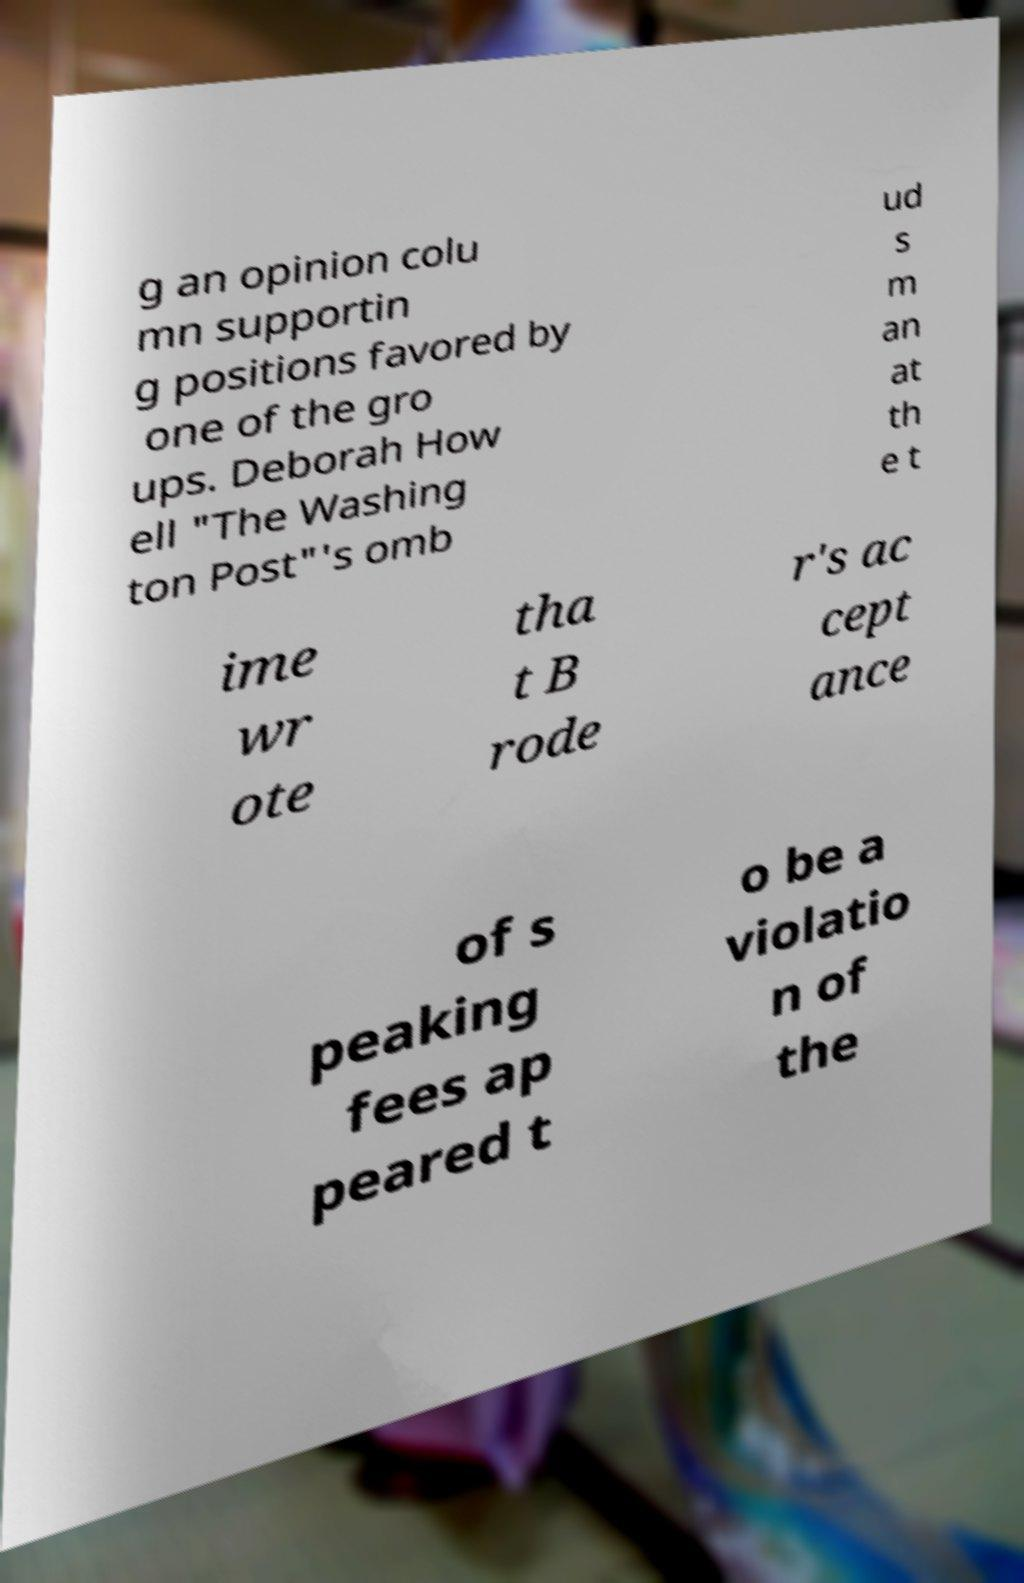Can you read and provide the text displayed in the image?This photo seems to have some interesting text. Can you extract and type it out for me? g an opinion colu mn supportin g positions favored by one of the gro ups. Deborah How ell "The Washing ton Post"'s omb ud s m an at th e t ime wr ote tha t B rode r's ac cept ance of s peaking fees ap peared t o be a violatio n of the 